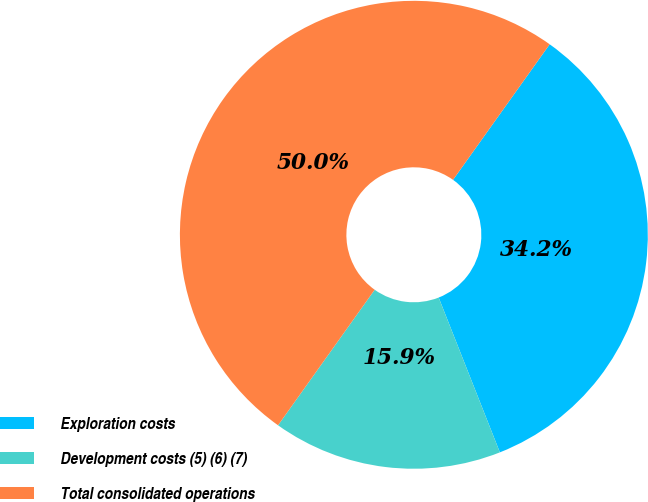<chart> <loc_0><loc_0><loc_500><loc_500><pie_chart><fcel>Exploration costs<fcel>Development costs (5) (6) (7)<fcel>Total consolidated operations<nl><fcel>34.15%<fcel>15.85%<fcel>50.0%<nl></chart> 